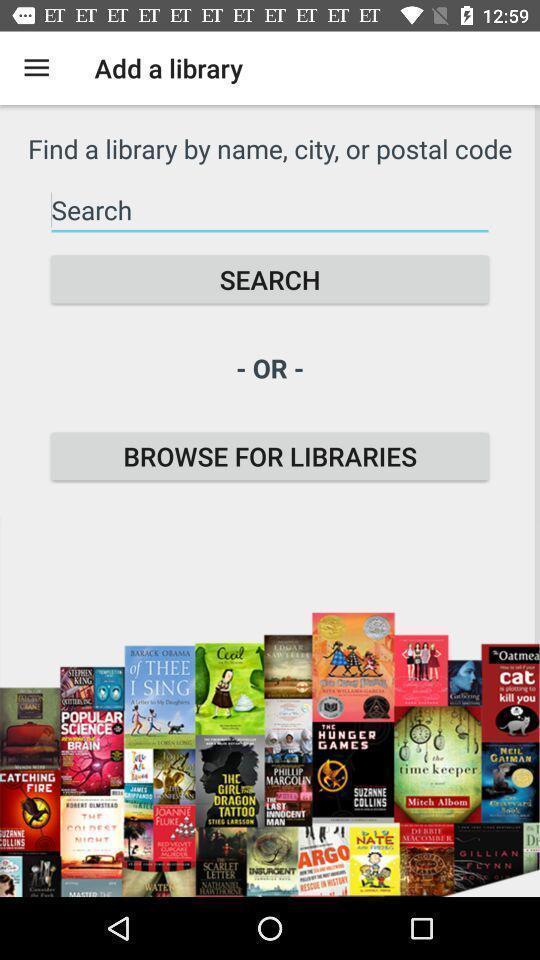Please provide a description for this image. Search page displayed of a ebook reading app. 